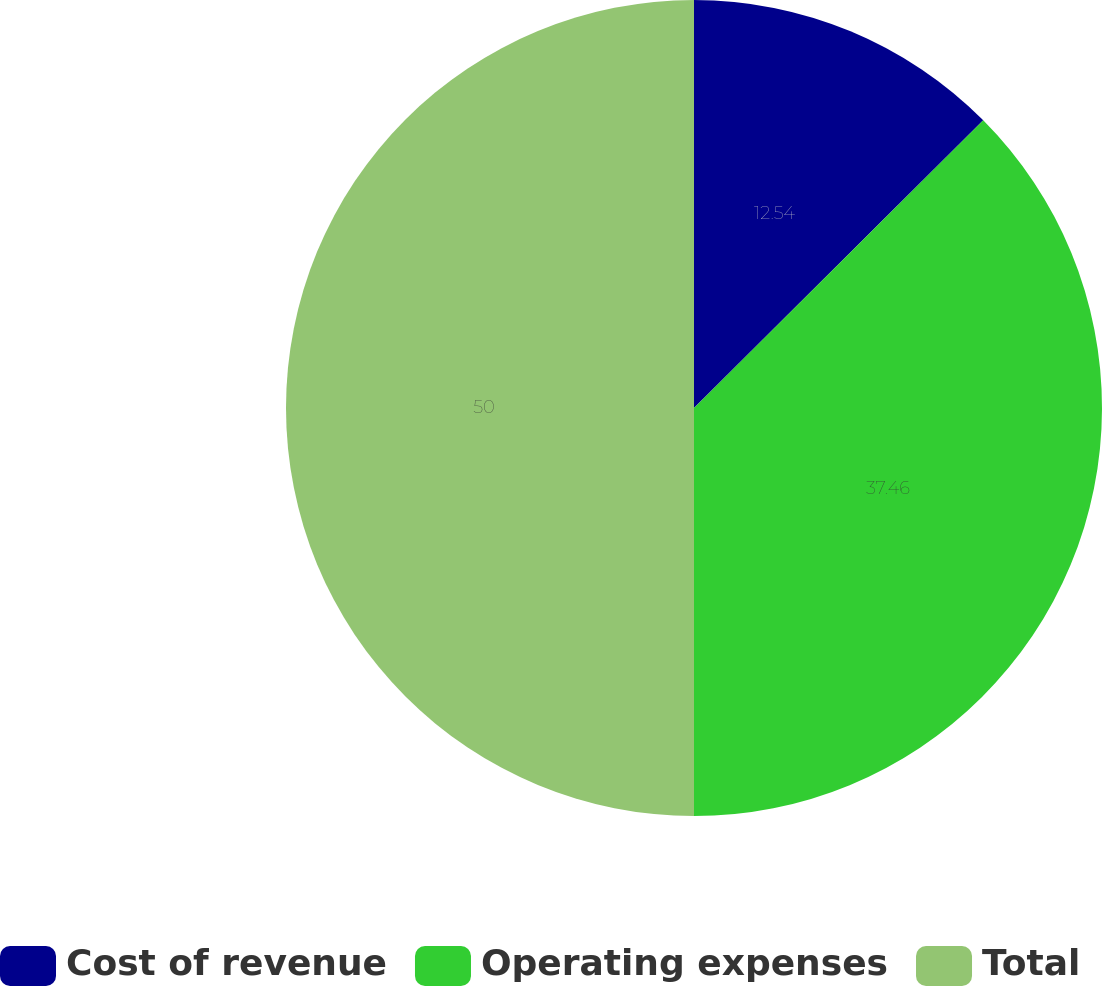Convert chart. <chart><loc_0><loc_0><loc_500><loc_500><pie_chart><fcel>Cost of revenue<fcel>Operating expenses<fcel>Total<nl><fcel>12.54%<fcel>37.46%<fcel>50.0%<nl></chart> 